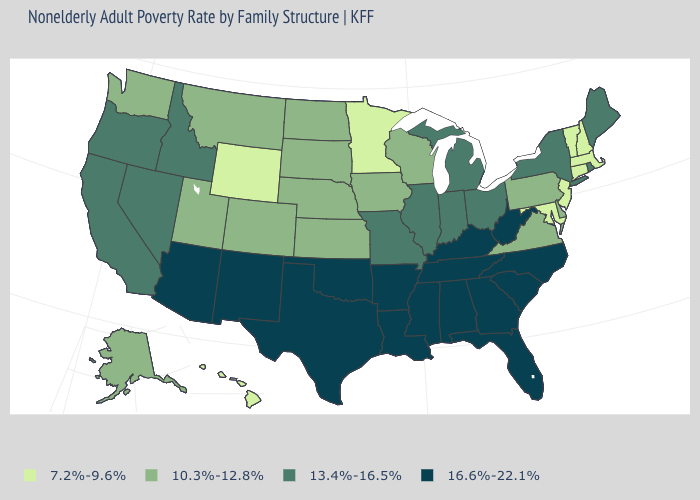Does Alaska have a higher value than Utah?
Concise answer only. No. Name the states that have a value in the range 10.3%-12.8%?
Be succinct. Alaska, Colorado, Delaware, Iowa, Kansas, Montana, Nebraska, North Dakota, Pennsylvania, South Dakota, Utah, Virginia, Washington, Wisconsin. Is the legend a continuous bar?
Give a very brief answer. No. How many symbols are there in the legend?
Give a very brief answer. 4. Which states have the lowest value in the USA?
Write a very short answer. Connecticut, Hawaii, Maryland, Massachusetts, Minnesota, New Hampshire, New Jersey, Vermont, Wyoming. What is the highest value in the USA?
Concise answer only. 16.6%-22.1%. What is the highest value in states that border Florida?
Give a very brief answer. 16.6%-22.1%. Does Wyoming have the highest value in the West?
Answer briefly. No. Does Maine have the same value as New York?
Be succinct. Yes. Which states have the lowest value in the West?
Answer briefly. Hawaii, Wyoming. Name the states that have a value in the range 16.6%-22.1%?
Give a very brief answer. Alabama, Arizona, Arkansas, Florida, Georgia, Kentucky, Louisiana, Mississippi, New Mexico, North Carolina, Oklahoma, South Carolina, Tennessee, Texas, West Virginia. Does Nevada have a higher value than Idaho?
Give a very brief answer. No. What is the highest value in states that border Georgia?
Short answer required. 16.6%-22.1%. Among the states that border New York , does Vermont have the lowest value?
Be succinct. Yes. Among the states that border Arizona , does Utah have the lowest value?
Be succinct. Yes. 